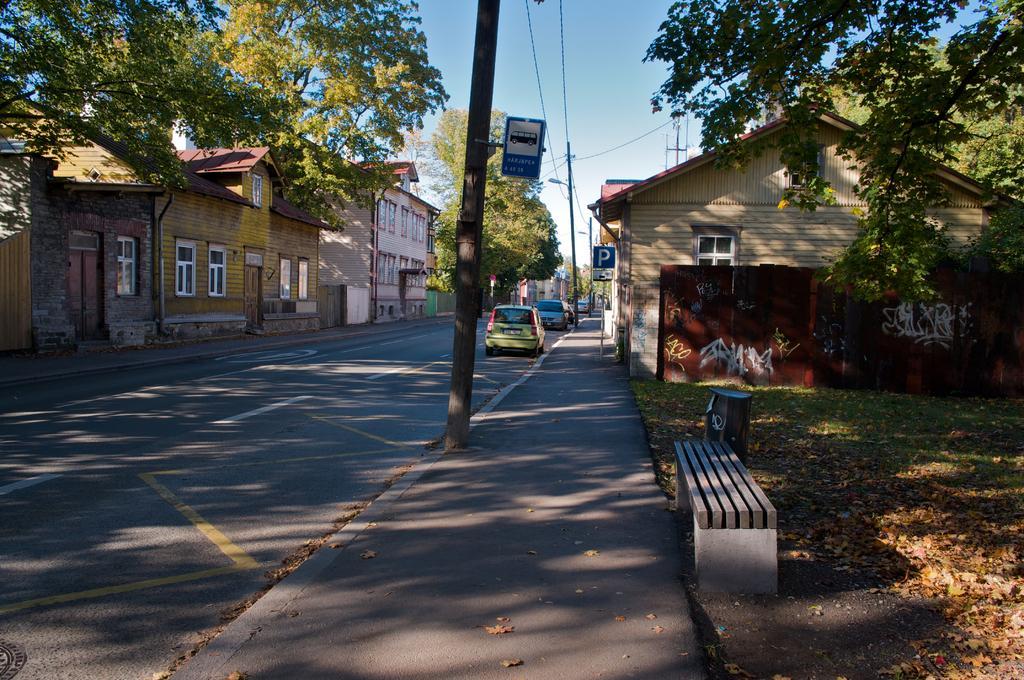Can you describe this image briefly? In the picture I can see vehicles parked on the side of the road, I can see current poles, wires, boards, trash cans, bench, dry leaves on the road, I can see grass, houses, trees and the sky in the background. 